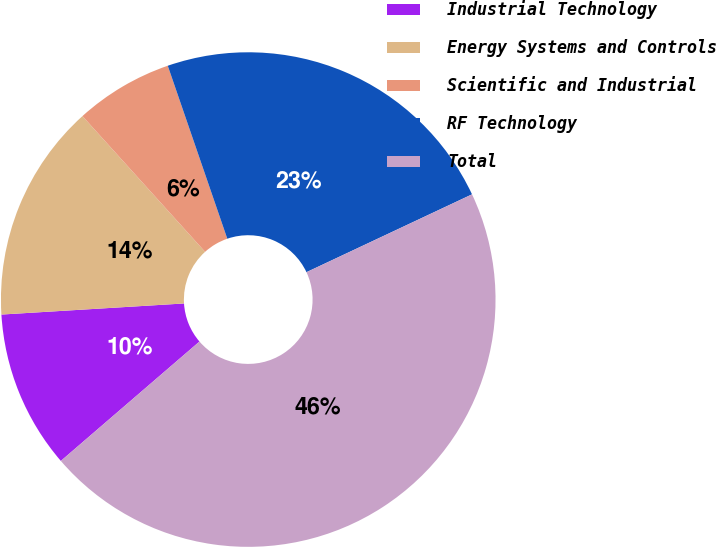Convert chart to OTSL. <chart><loc_0><loc_0><loc_500><loc_500><pie_chart><fcel>Industrial Technology<fcel>Energy Systems and Controls<fcel>Scientific and Industrial<fcel>RF Technology<fcel>Total<nl><fcel>10.35%<fcel>14.27%<fcel>6.42%<fcel>23.28%<fcel>45.68%<nl></chart> 